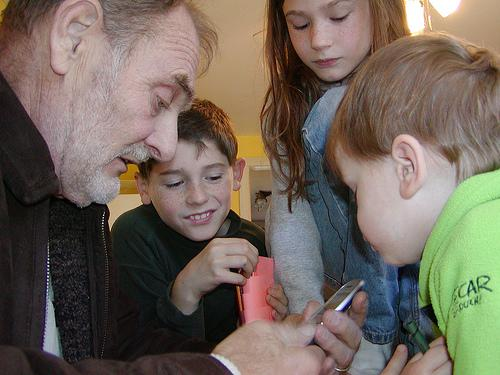Question: who is wearing a green shirt?
Choices:
A. Girl on left.
B. Boy on right.
C. Woman on left.
D. Man on left.
Answer with the letter. Answer: B Question: what is a man looking at?
Choices:
A. Ipad.
B. Laptop.
C. Camera.
D. Cell phone.
Answer with the letter. Answer: D Question: how many kids are there?
Choices:
A. Two.
B. Four.
C. Three.
D. Five.
Answer with the letter. Answer: C Question: where is a cell phone?
Choices:
A. In a woman's hands.
B. In a girl's hands.
C. In a boy's hands.
D. In a man's hands.
Answer with the letter. Answer: D 